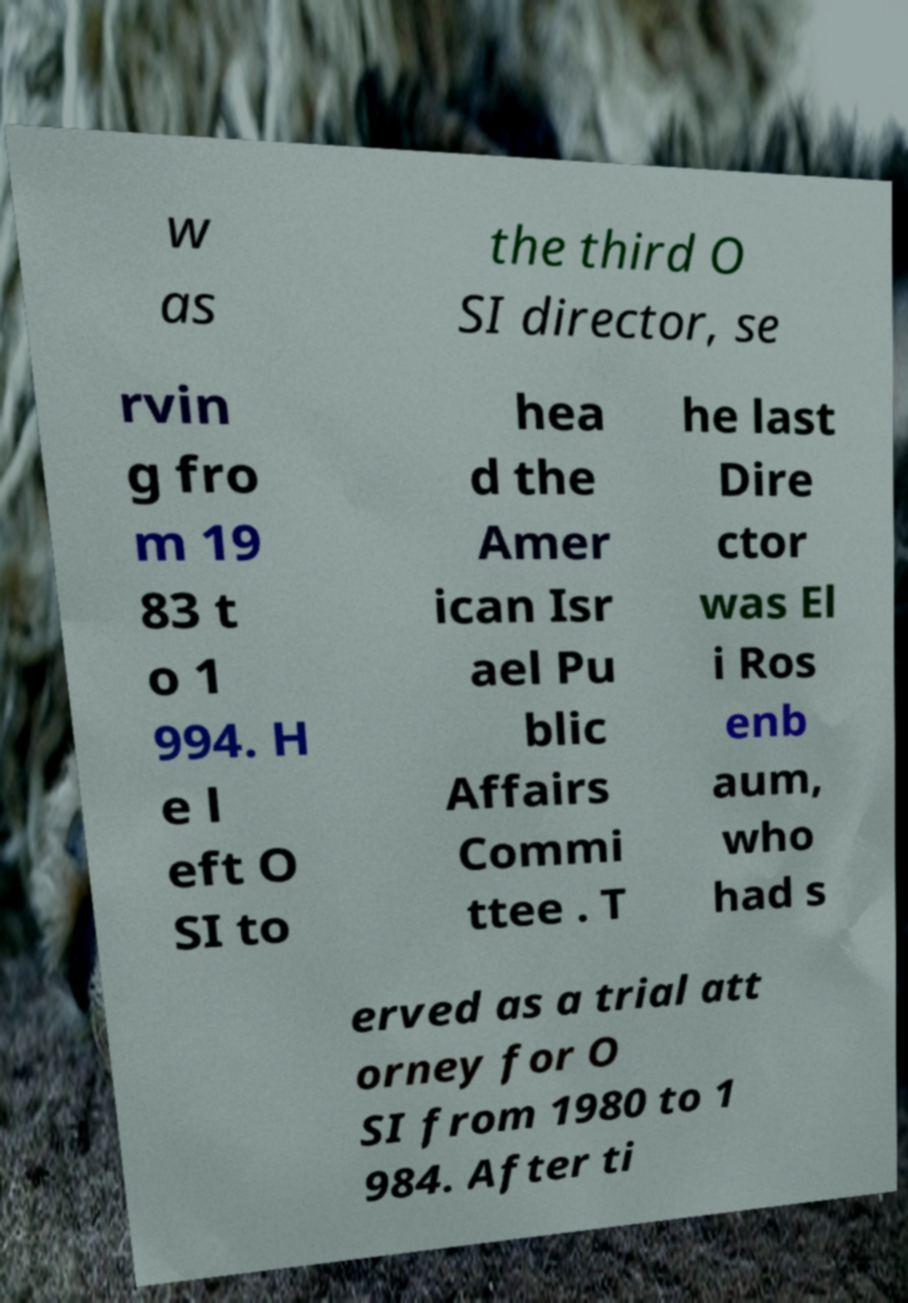For documentation purposes, I need the text within this image transcribed. Could you provide that? w as the third O SI director, se rvin g fro m 19 83 t o 1 994. H e l eft O SI to hea d the Amer ican Isr ael Pu blic Affairs Commi ttee . T he last Dire ctor was El i Ros enb aum, who had s erved as a trial att orney for O SI from 1980 to 1 984. After ti 